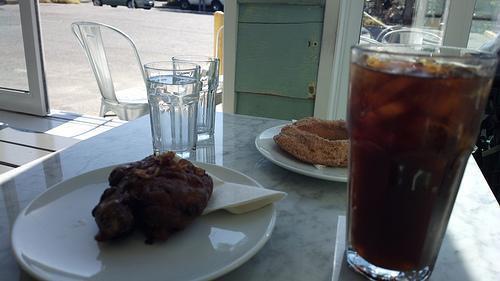How many plates are in the picture?
Give a very brief answer. 2. 